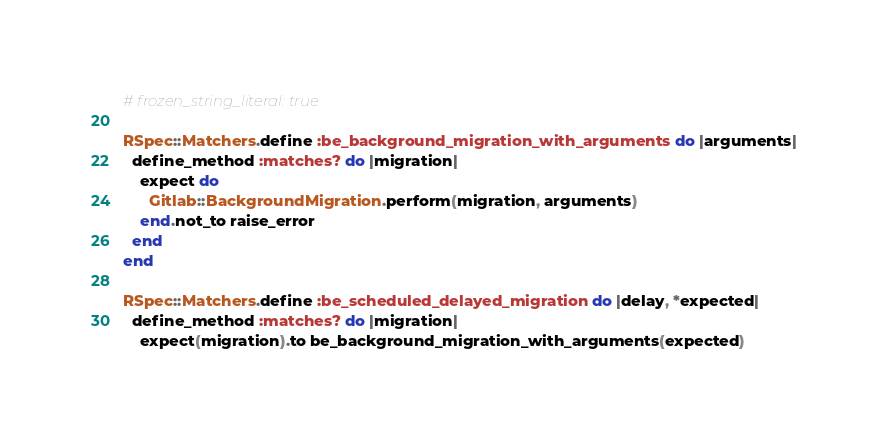Convert code to text. <code><loc_0><loc_0><loc_500><loc_500><_Ruby_># frozen_string_literal: true

RSpec::Matchers.define :be_background_migration_with_arguments do |arguments|
  define_method :matches? do |migration|
    expect do
      Gitlab::BackgroundMigration.perform(migration, arguments)
    end.not_to raise_error
  end
end

RSpec::Matchers.define :be_scheduled_delayed_migration do |delay, *expected|
  define_method :matches? do |migration|
    expect(migration).to be_background_migration_with_arguments(expected)
</code> 